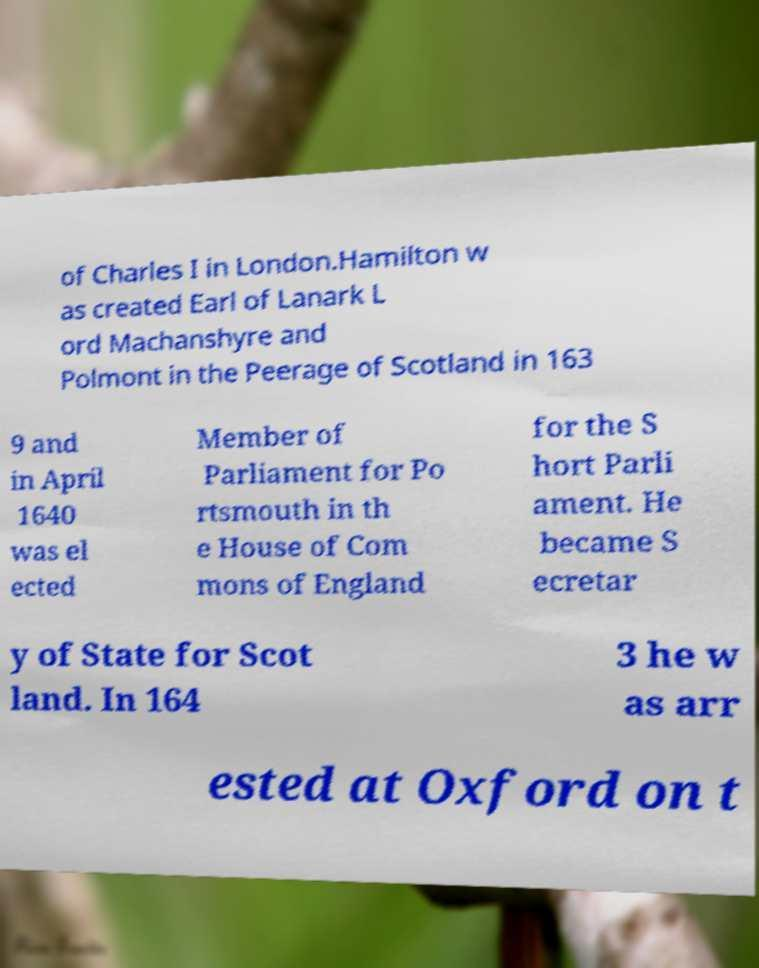Could you extract and type out the text from this image? of Charles I in London.Hamilton w as created Earl of Lanark L ord Machanshyre and Polmont in the Peerage of Scotland in 163 9 and in April 1640 was el ected Member of Parliament for Po rtsmouth in th e House of Com mons of England for the S hort Parli ament. He became S ecretar y of State for Scot land. In 164 3 he w as arr ested at Oxford on t 